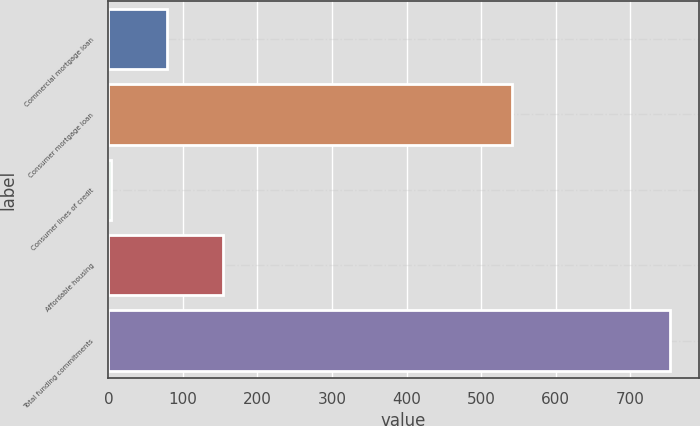Convert chart. <chart><loc_0><loc_0><loc_500><loc_500><bar_chart><fcel>Commercial mortgage loan<fcel>Consumer mortgage loan<fcel>Consumer lines of credit<fcel>Affordable housing<fcel>Total funding commitments<nl><fcel>79<fcel>542<fcel>4<fcel>154<fcel>754<nl></chart> 